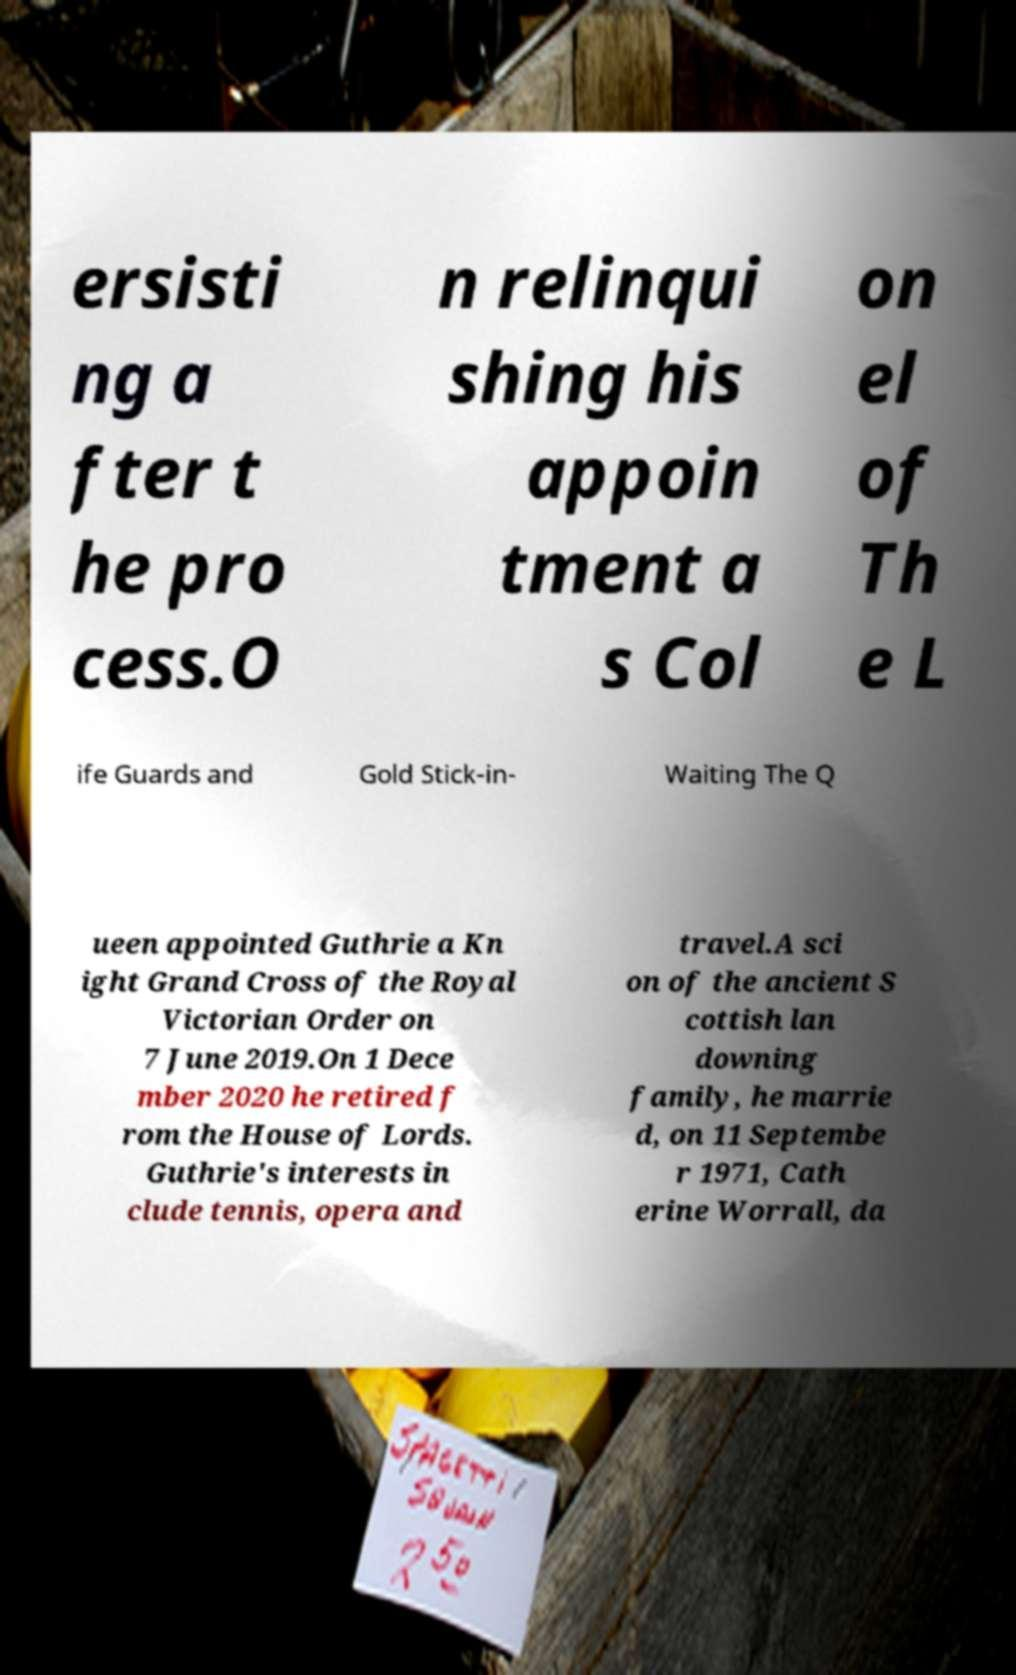Can you accurately transcribe the text from the provided image for me? ersisti ng a fter t he pro cess.O n relinqui shing his appoin tment a s Col on el of Th e L ife Guards and Gold Stick-in- Waiting The Q ueen appointed Guthrie a Kn ight Grand Cross of the Royal Victorian Order on 7 June 2019.On 1 Dece mber 2020 he retired f rom the House of Lords. Guthrie's interests in clude tennis, opera and travel.A sci on of the ancient S cottish lan downing family, he marrie d, on 11 Septembe r 1971, Cath erine Worrall, da 